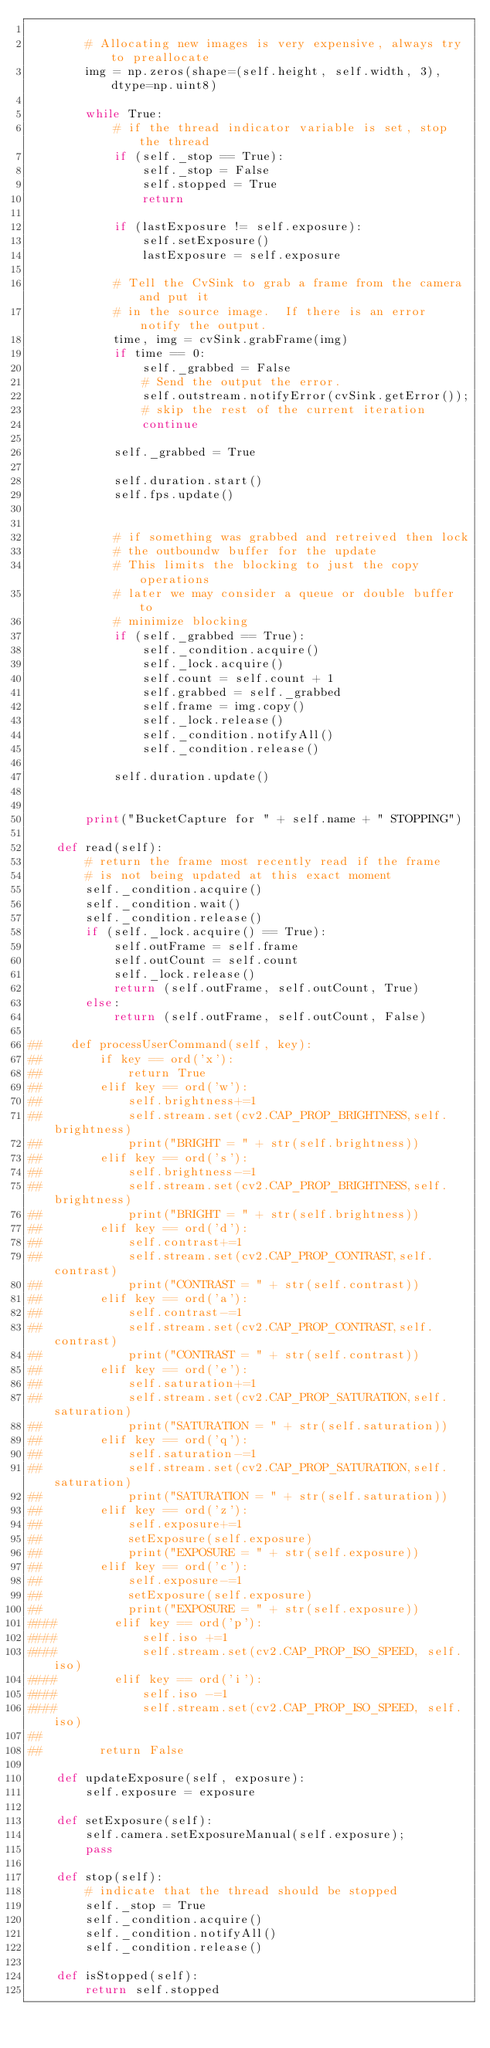<code> <loc_0><loc_0><loc_500><loc_500><_Python_>
        # Allocating new images is very expensive, always try to preallocate
        img = np.zeros(shape=(self.height, self.width, 3), dtype=np.uint8)    

        while True:
            # if the thread indicator variable is set, stop the thread
            if (self._stop == True):
                self._stop = False
                self.stopped = True
                return
            
            if (lastExposure != self.exposure):
                self.setExposure()
                lastExposure = self.exposure
                
            # Tell the CvSink to grab a frame from the camera and put it
            # in the source image.  If there is an error notify the output.
            time, img = cvSink.grabFrame(img)
            if time == 0:
                self._grabbed = False
                # Send the output the error.
                self.outstream.notifyError(cvSink.getError());
                # skip the rest of the current iteration
                continue

            self._grabbed = True                
            
            self.duration.start()
            self.fps.update()
            
            
            # if something was grabbed and retreived then lock
            # the outboundw buffer for the update
            # This limits the blocking to just the copy operations
            # later we may consider a queue or double buffer to
            # minimize blocking
            if (self._grabbed == True):
                self._condition.acquire()
                self._lock.acquire()
                self.count = self.count + 1
                self.grabbed = self._grabbed
                self.frame = img.copy()
                self._lock.release()
                self._condition.notifyAll()
                self._condition.release()

            self.duration.update()

                
        print("BucketCapture for " + self.name + " STOPPING")

    def read(self):
        # return the frame most recently read if the frame
        # is not being updated at this exact moment
        self._condition.acquire()
        self._condition.wait()
        self._condition.release()
        if (self._lock.acquire() == True):
            self.outFrame = self.frame
            self.outCount = self.count
            self._lock.release()
            return (self.outFrame, self.outCount, True)
        else:
            return (self.outFrame, self.outCount, False)

##    def processUserCommand(self, key):
##        if key == ord('x'):
##            return True
##        elif key == ord('w'):
##            self.brightness+=1
##            self.stream.set(cv2.CAP_PROP_BRIGHTNESS,self.brightness)
##            print("BRIGHT = " + str(self.brightness))
##        elif key == ord('s'):
##            self.brightness-=1
##            self.stream.set(cv2.CAP_PROP_BRIGHTNESS,self.brightness)
##            print("BRIGHT = " + str(self.brightness))
##        elif key == ord('d'):
##            self.contrast+=1
##            self.stream.set(cv2.CAP_PROP_CONTRAST,self.contrast)
##            print("CONTRAST = " + str(self.contrast))
##        elif key == ord('a'):
##            self.contrast-=1
##            self.stream.set(cv2.CAP_PROP_CONTRAST,self.contrast)
##            print("CONTRAST = " + str(self.contrast))
##        elif key == ord('e'):
##            self.saturation+=1
##            self.stream.set(cv2.CAP_PROP_SATURATION,self.saturation)
##            print("SATURATION = " + str(self.saturation))
##        elif key == ord('q'):
##            self.saturation-=1
##            self.stream.set(cv2.CAP_PROP_SATURATION,self.saturation)
##            print("SATURATION = " + str(self.saturation))
##        elif key == ord('z'):
##            self.exposure+=1
##            setExposure(self.exposure)
##            print("EXPOSURE = " + str(self.exposure))
##        elif key == ord('c'):
##            self.exposure-=1
##            setExposure(self.exposure)
##            print("EXPOSURE = " + str(self.exposure))
####        elif key == ord('p'):
####            self.iso +=1
####            self.stream.set(cv2.CAP_PROP_ISO_SPEED, self.iso)
####        elif key == ord('i'):
####            self.iso -=1
####            self.stream.set(cv2.CAP_PROP_ISO_SPEED, self.iso)
##
##        return False

    def updateExposure(self, exposure):
        self.exposure = exposure
        
    def setExposure(self):
        self.camera.setExposureManual(self.exposure);
        pass
    
    def stop(self):
        # indicate that the thread should be stopped
        self._stop = True
        self._condition.acquire()
        self._condition.notifyAll()
        self._condition.release()

    def isStopped(self):
        return self.stopped
    
</code> 